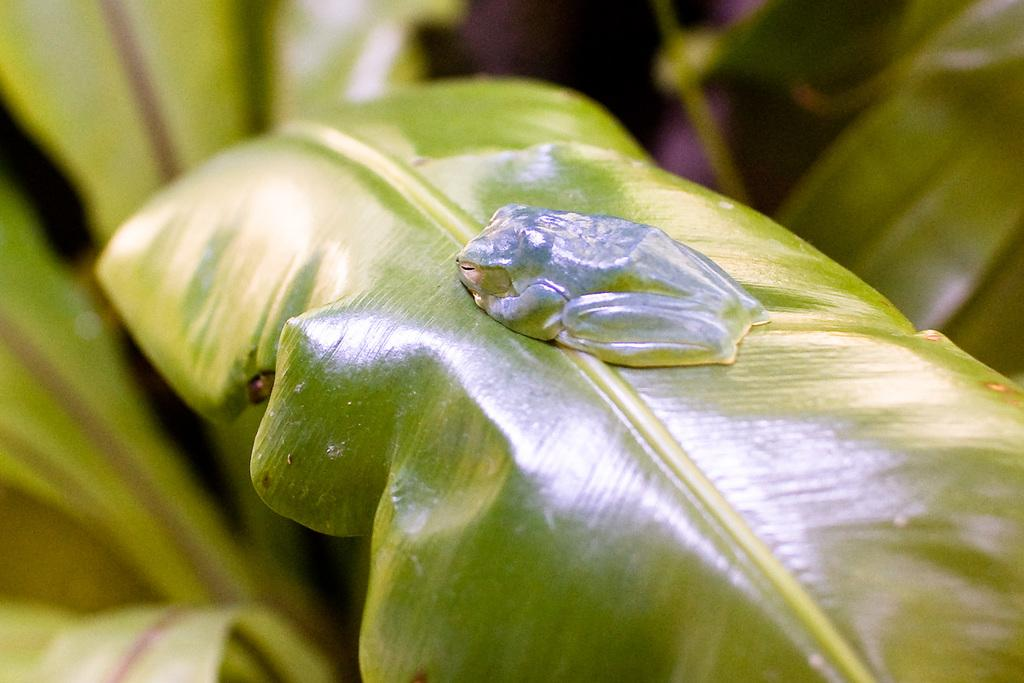What type of creature can be seen in the image? There is an insect in the image. Where is the insect located? The insect is on a leaf. What color is the leaf? The leaf is green. Can you describe the background of the image? The background of the image is blurred. What type of jewel is the insect holding in the image? There is no jewel present in the image; the insect is on a leaf. 